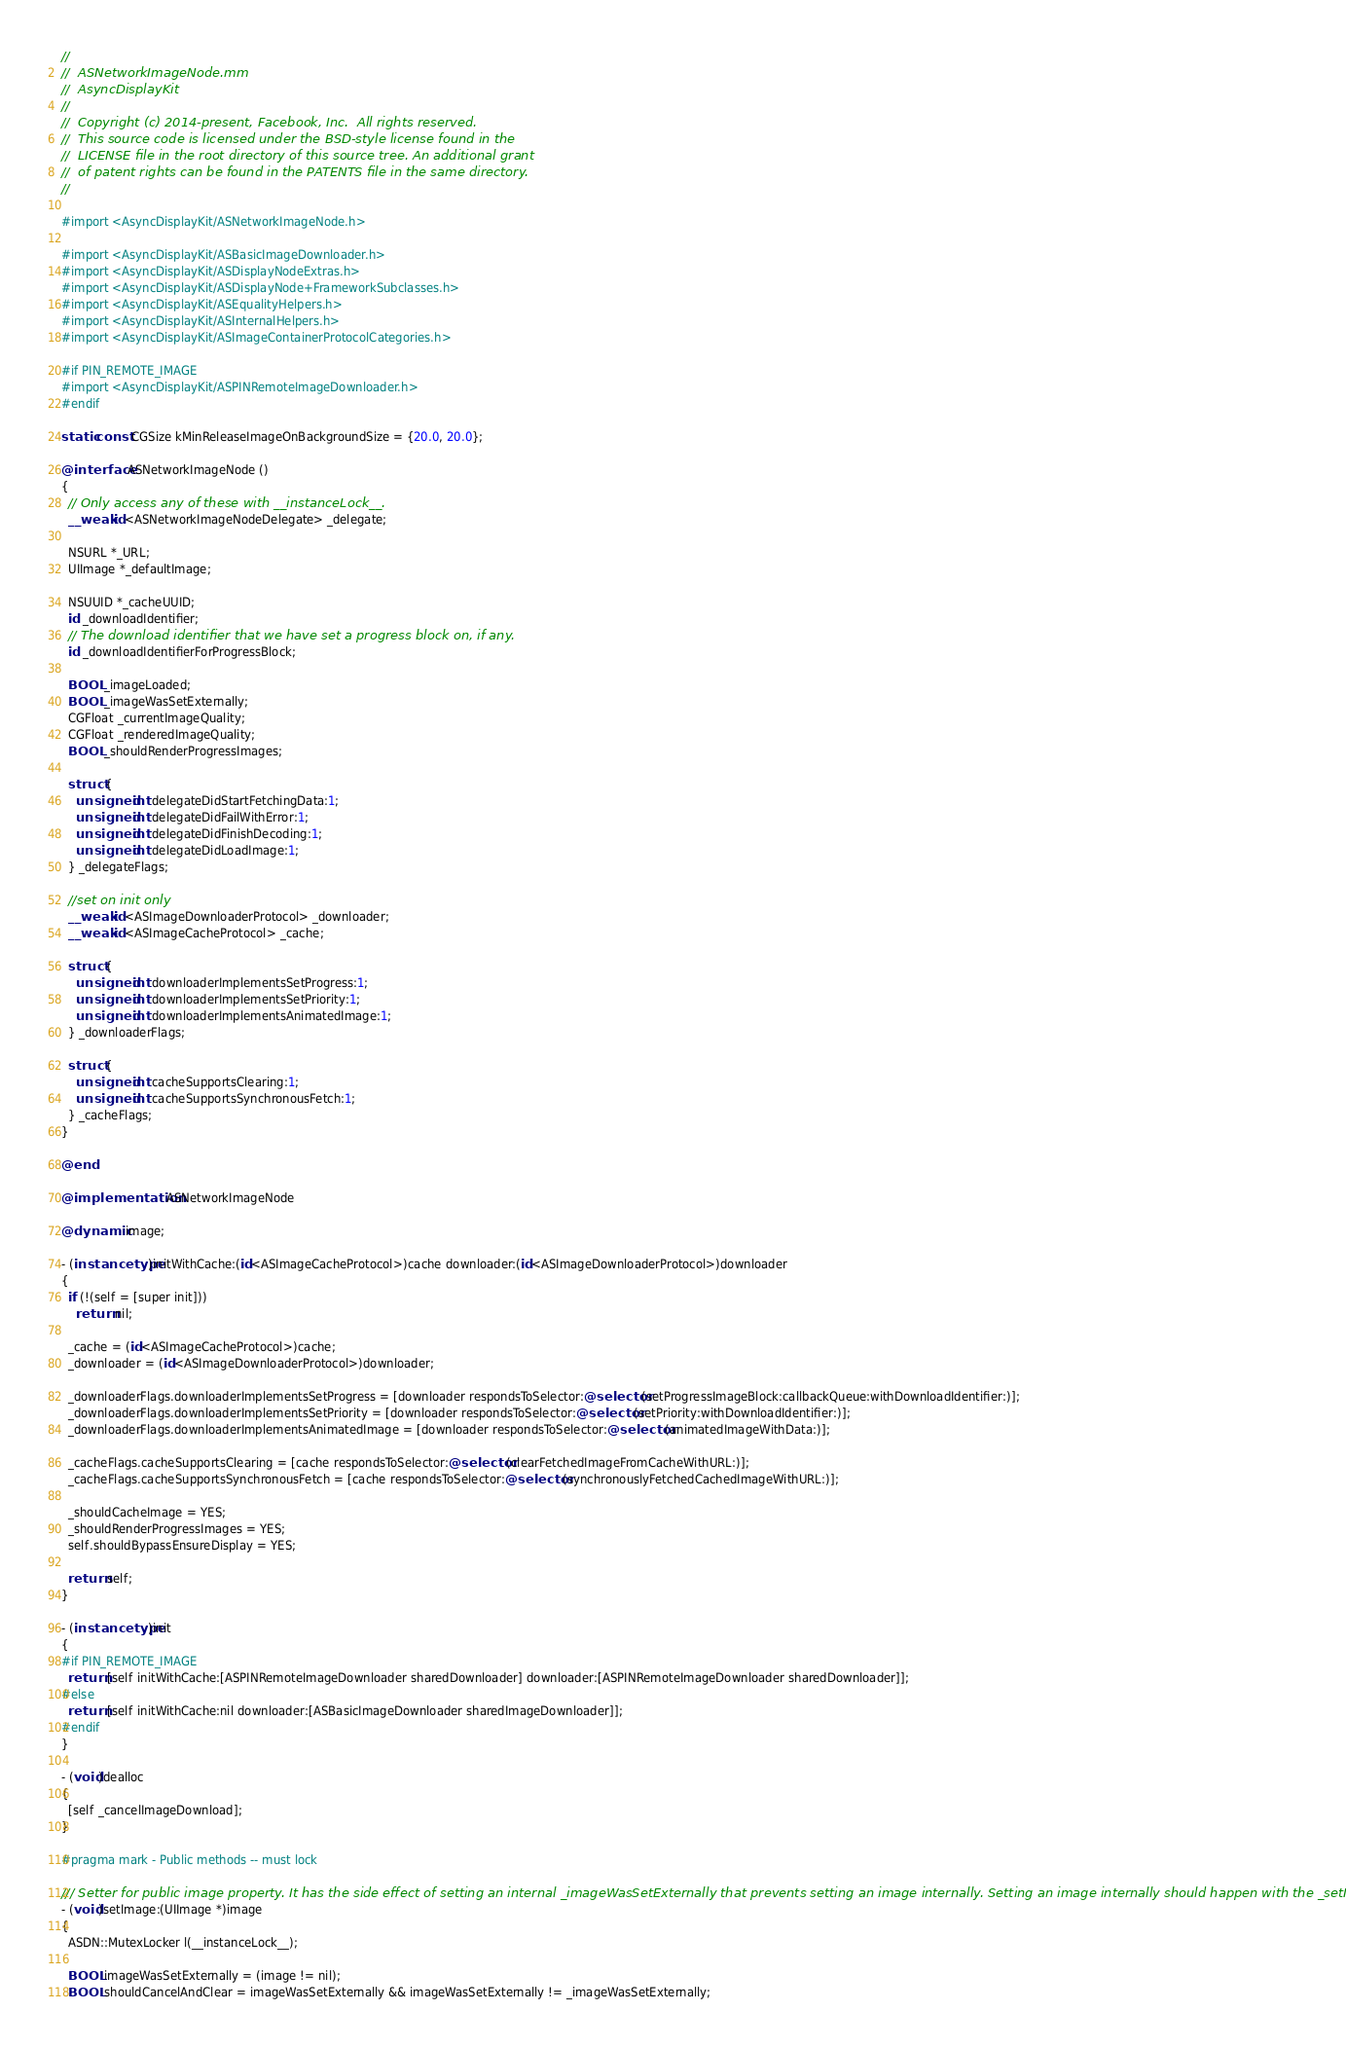<code> <loc_0><loc_0><loc_500><loc_500><_ObjectiveC_>//
//  ASNetworkImageNode.mm
//  AsyncDisplayKit
//
//  Copyright (c) 2014-present, Facebook, Inc.  All rights reserved.
//  This source code is licensed under the BSD-style license found in the
//  LICENSE file in the root directory of this source tree. An additional grant
//  of patent rights can be found in the PATENTS file in the same directory.
//

#import <AsyncDisplayKit/ASNetworkImageNode.h>

#import <AsyncDisplayKit/ASBasicImageDownloader.h>
#import <AsyncDisplayKit/ASDisplayNodeExtras.h>
#import <AsyncDisplayKit/ASDisplayNode+FrameworkSubclasses.h>
#import <AsyncDisplayKit/ASEqualityHelpers.h>
#import <AsyncDisplayKit/ASInternalHelpers.h>
#import <AsyncDisplayKit/ASImageContainerProtocolCategories.h>

#if PIN_REMOTE_IMAGE
#import <AsyncDisplayKit/ASPINRemoteImageDownloader.h>
#endif

static const CGSize kMinReleaseImageOnBackgroundSize = {20.0, 20.0};

@interface ASNetworkImageNode ()
{
  // Only access any of these with __instanceLock__.
  __weak id<ASNetworkImageNodeDelegate> _delegate;

  NSURL *_URL;
  UIImage *_defaultImage;

  NSUUID *_cacheUUID;
  id _downloadIdentifier;
  // The download identifier that we have set a progress block on, if any.
  id _downloadIdentifierForProgressBlock;

  BOOL _imageLoaded;
  BOOL _imageWasSetExternally;
  CGFloat _currentImageQuality;
  CGFloat _renderedImageQuality;
  BOOL _shouldRenderProgressImages;

  struct {
    unsigned int delegateDidStartFetchingData:1;
    unsigned int delegateDidFailWithError:1;
    unsigned int delegateDidFinishDecoding:1;
    unsigned int delegateDidLoadImage:1;
  } _delegateFlags;

  //set on init only
  __weak id<ASImageDownloaderProtocol> _downloader;
  __weak id<ASImageCacheProtocol> _cache;
  
  struct {
    unsigned int downloaderImplementsSetProgress:1;
    unsigned int downloaderImplementsSetPriority:1;
    unsigned int downloaderImplementsAnimatedImage:1;
  } _downloaderFlags;

  struct {
    unsigned int cacheSupportsClearing:1;
    unsigned int cacheSupportsSynchronousFetch:1;
  } _cacheFlags;
}

@end

@implementation ASNetworkImageNode

@dynamic image;

- (instancetype)initWithCache:(id<ASImageCacheProtocol>)cache downloader:(id<ASImageDownloaderProtocol>)downloader
{
  if (!(self = [super init]))
    return nil;

  _cache = (id<ASImageCacheProtocol>)cache;
  _downloader = (id<ASImageDownloaderProtocol>)downloader;
  
  _downloaderFlags.downloaderImplementsSetProgress = [downloader respondsToSelector:@selector(setProgressImageBlock:callbackQueue:withDownloadIdentifier:)];
  _downloaderFlags.downloaderImplementsSetPriority = [downloader respondsToSelector:@selector(setPriority:withDownloadIdentifier:)];
  _downloaderFlags.downloaderImplementsAnimatedImage = [downloader respondsToSelector:@selector(animatedImageWithData:)];

  _cacheFlags.cacheSupportsClearing = [cache respondsToSelector:@selector(clearFetchedImageFromCacheWithURL:)];
  _cacheFlags.cacheSupportsSynchronousFetch = [cache respondsToSelector:@selector(synchronouslyFetchedCachedImageWithURL:)];
  
  _shouldCacheImage = YES;
  _shouldRenderProgressImages = YES;
  self.shouldBypassEnsureDisplay = YES;

  return self;
}

- (instancetype)init
{
#if PIN_REMOTE_IMAGE
  return [self initWithCache:[ASPINRemoteImageDownloader sharedDownloader] downloader:[ASPINRemoteImageDownloader sharedDownloader]];
#else
  return [self initWithCache:nil downloader:[ASBasicImageDownloader sharedImageDownloader]];
#endif
}

- (void)dealloc
{
  [self _cancelImageDownload];
}

#pragma mark - Public methods -- must lock

/// Setter for public image property. It has the side effect of setting an internal _imageWasSetExternally that prevents setting an image internally. Setting an image internally should happen with the _setImage: method
- (void)setImage:(UIImage *)image
{
  ASDN::MutexLocker l(__instanceLock__);
  
  BOOL imageWasSetExternally = (image != nil);
  BOOL shouldCancelAndClear = imageWasSetExternally && imageWasSetExternally != _imageWasSetExternally;</code> 